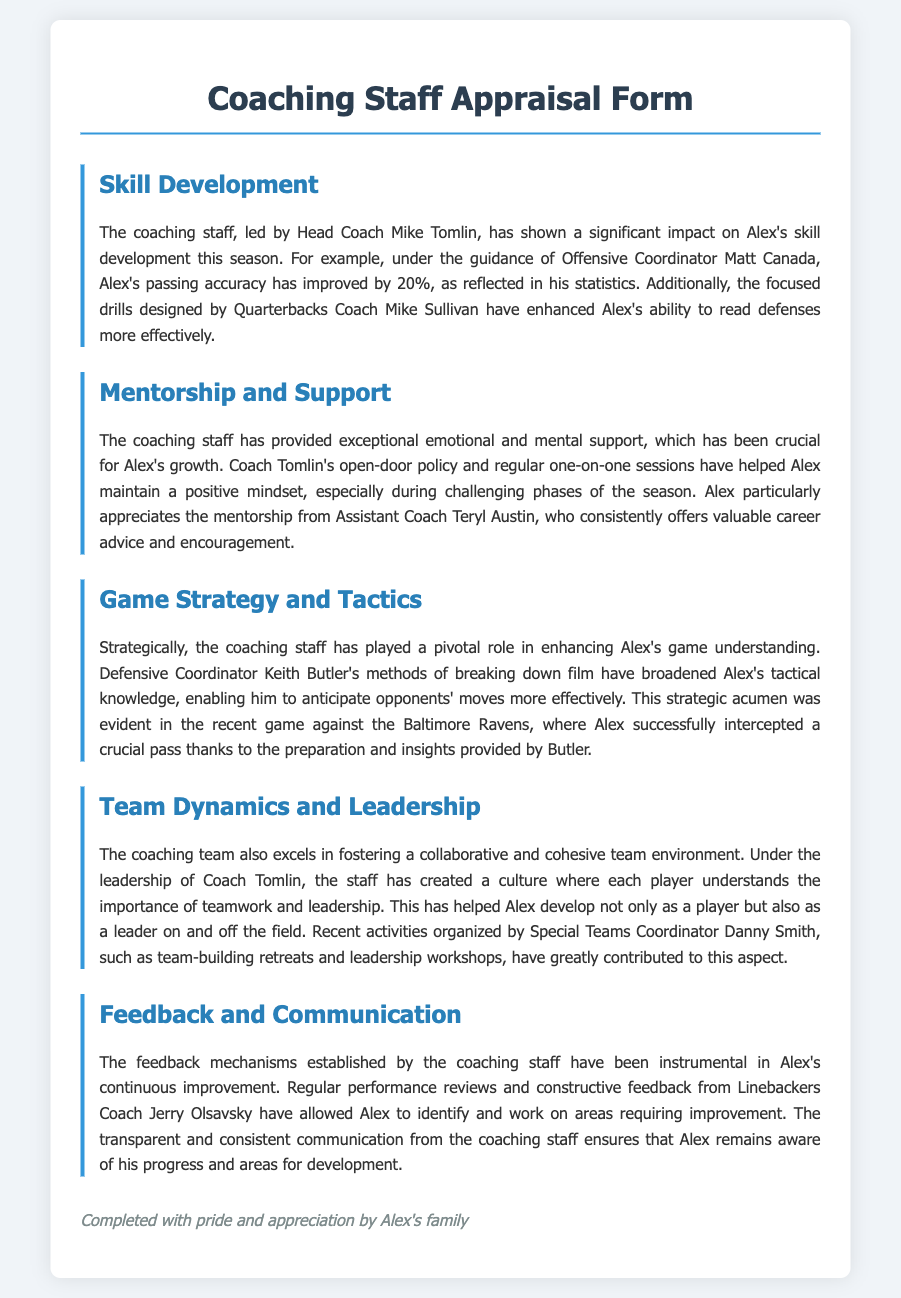what is the name of the head coach? The head coach's name is mentioned in the section about skill development, specifically as Mike Tomlin.
Answer: Mike Tomlin by what percentage has Alex's passing accuracy improved? The document states that Alex's passing accuracy has improved by 20% under the guidance of Offensive Coordinator Matt Canada.
Answer: 20% who is the Quarterbacks Coach? The document specifies that the Quarterbacks Coach is Mike Sullivan, noted for enhancing Alex's ability to read defenses.
Answer: Mike Sullivan what methods did Defensive Coordinator Keith Butler use to enhance Alex's tactical knowledge? The document indicates that Keith Butler's methods of breaking down film have broadened Alex's tactical knowledge.
Answer: Breaking down film which coach provided emotional and mental support? The document emphasizes the emotional and mental support provided by Coach Tomlin, particularly through his open-door policy.
Answer: Coach Tomlin how did the coaching staff contribute to team dynamics? The document highlights that the coaching team created a culture promoting teamwork and leadership, especially through activities organized by Special Teams Coordinator Danny Smith.
Answer: Teamwork and leadership culture what type of reviews help Alex identify areas for improvement? Regular performance reviews conducted by Linebackers Coach Jerry Olsavsky help Alex identify areas needing improvement.
Answer: Performance reviews who is noted for offering career advice to Alex? The document mentions that Assistant Coach Teryl Austin consistently offers valuable career advice and encouragement to Alex.
Answer: Teryl Austin what aspect did the coaching staff improve in Alex apart from skills? The coaching staff helped improve Alex's leadership abilities as noted in the section about team dynamics.
Answer: Leadership abilities 